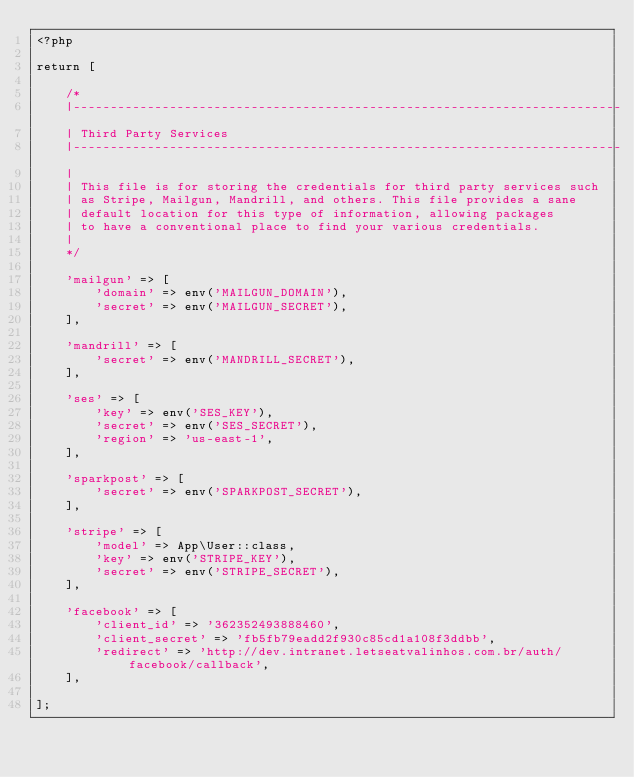Convert code to text. <code><loc_0><loc_0><loc_500><loc_500><_PHP_><?php

return [

    /*
    |--------------------------------------------------------------------------
    | Third Party Services
    |--------------------------------------------------------------------------
    |
    | This file is for storing the credentials for third party services such
    | as Stripe, Mailgun, Mandrill, and others. This file provides a sane
    | default location for this type of information, allowing packages
    | to have a conventional place to find your various credentials.
    |
    */

    'mailgun' => [
        'domain' => env('MAILGUN_DOMAIN'),
        'secret' => env('MAILGUN_SECRET'),
    ],

    'mandrill' => [
        'secret' => env('MANDRILL_SECRET'),
    ],

    'ses' => [
        'key' => env('SES_KEY'),
        'secret' => env('SES_SECRET'),
        'region' => 'us-east-1',
    ],

    'sparkpost' => [
        'secret' => env('SPARKPOST_SECRET'),
    ],

    'stripe' => [
        'model' => App\User::class,
        'key' => env('STRIPE_KEY'),
        'secret' => env('STRIPE_SECRET'),
    ],

    'facebook' => [
        'client_id' => '362352493888460',
        'client_secret' => 'fb5fb79eadd2f930c85cd1a108f3ddbb',
        'redirect' => 'http://dev.intranet.letseatvalinhos.com.br/auth/facebook/callback',
    ],

];
</code> 